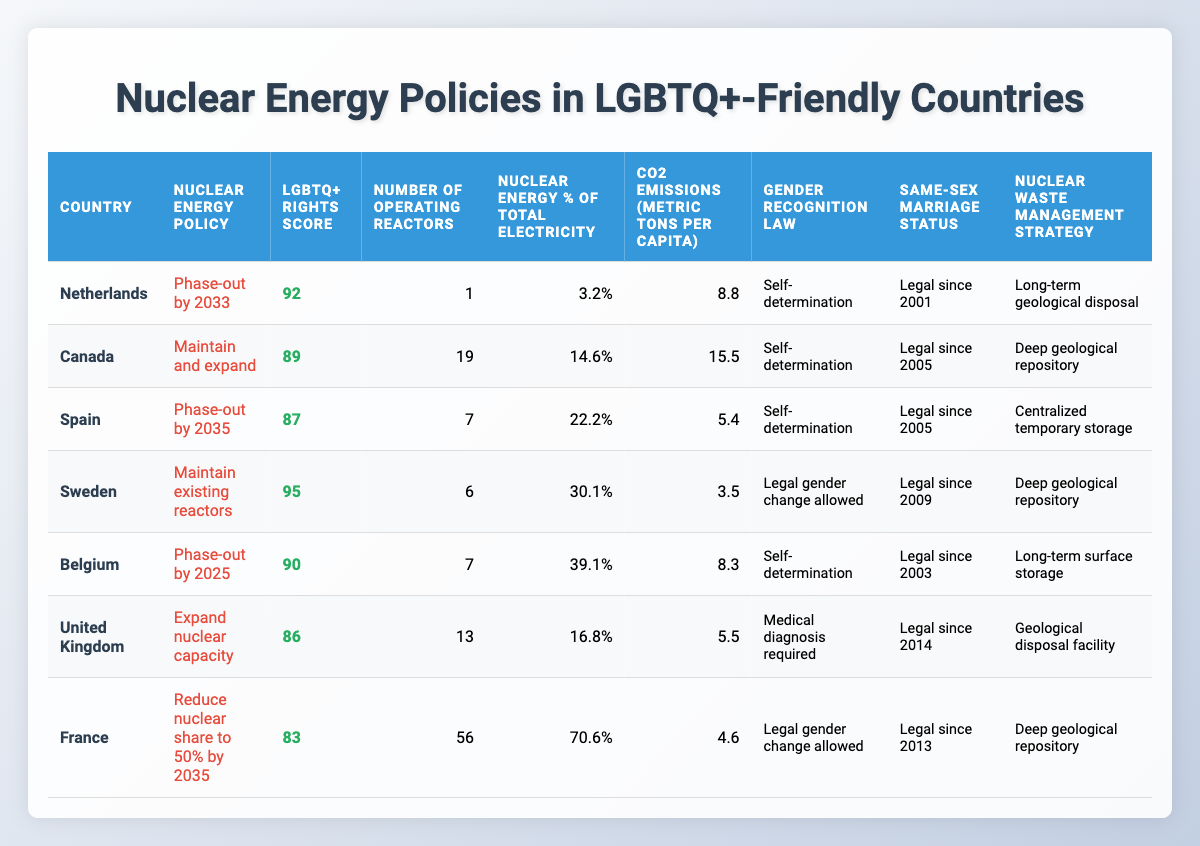What's the LGBTQ+ rights score for Sweden? The table lists Sweden's LGBTQ+ Rights Score as 95.
Answer: 95 What is the nuclear energy policy of Belgium? The table indicates that Belgium's nuclear energy policy is to phase-out by 2025.
Answer: Phase-out by 2025 How many operating reactors are there in Canada? According to the table, Canada has 19 operating reactors.
Answer: 19 Which country has the highest percentage of nuclear energy in total electricity? The table shows that France has the highest percentage at 70.6%.
Answer: France What are the CO2 emissions per capita for Spain? The table states that Spain has CO2 emissions of 5.4 metric tons per capita.
Answer: 5.4 Is same-sex marriage legalized in the Netherlands? The table confirms that same-sex marriage has been legal in the Netherlands since 2001.
Answer: Yes Which country with a higher LGBTQ+ Rights Score than United Kingdom also plans to phase out nuclear energy? The table shows that Belgium (score of 90) plans to phase out and has a higher score than the UK (86).
Answer: Belgium What is the average number of operating reactors in the countries listed? The operating reactors are: 1 (Netherlands), 19 (Canada), 7 (Spain), 6 (Sweden), 7 (Belgium), 13 (UK), and 56 (France). Sum = 109, which divided by 7 gives an average of 15.7.
Answer: 15.7 Does any country on the list utilize deep geological repository for nuclear waste management and have same-sex marriage legalized? The countries that meet these criteria are Canada, Sweden, and France, as they all have deep geological repository and have legalized same-sex marriage.
Answer: Yes Which country has the lowest CO2 emissions per capita and how does it correlate with its nuclear energy policy? Sweden has the lowest CO2 emissions at 3.5, and its policy is to maintain existing reactors, which may contribute to lower emissions.
Answer: Sweden What’s the difference in LGBTQ+ rights scores between the Netherlands and France? The Netherlands has a score of 92 and France has 83, so the difference is 9.
Answer: 9 